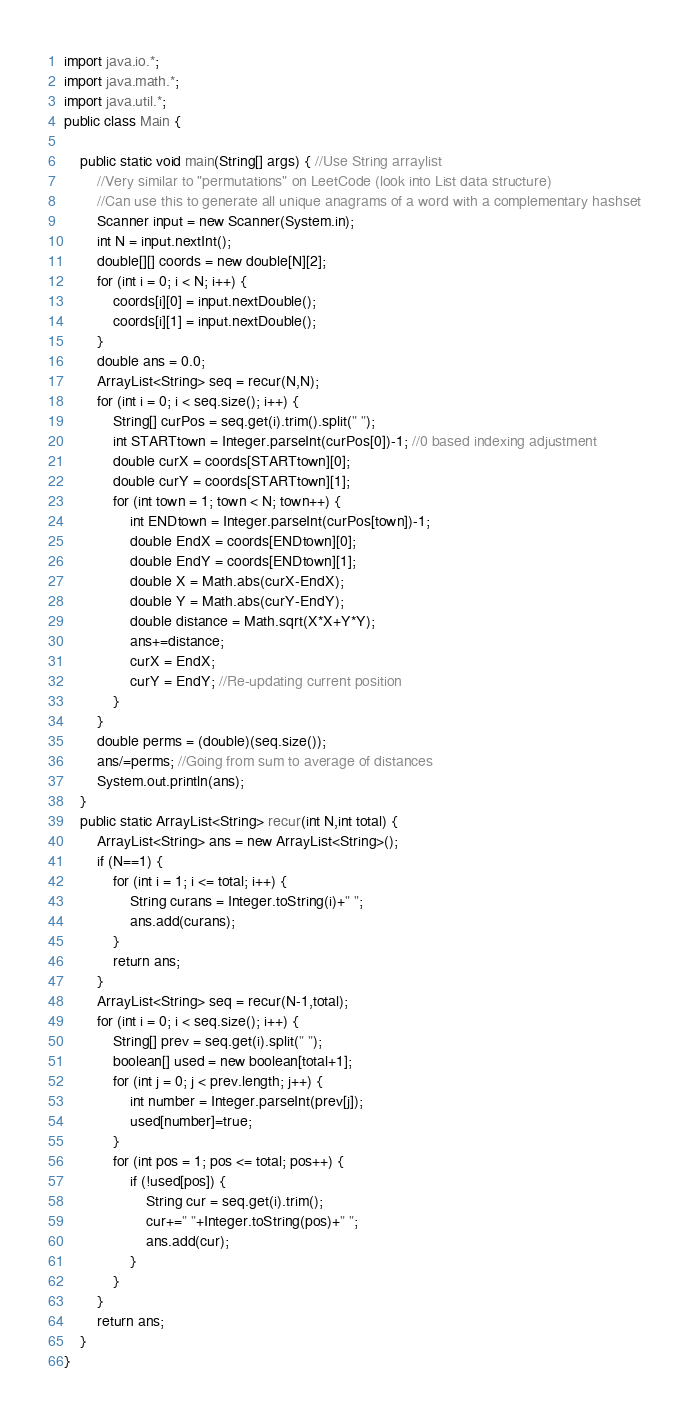<code> <loc_0><loc_0><loc_500><loc_500><_Java_>import java.io.*;
import java.math.*;
import java.util.*;
public class Main { 

	public static void main(String[] args) { //Use String arraylist
		//Very similar to "permutations" on LeetCode (look into List data structure)
		//Can use this to generate all unique anagrams of a word with a complementary hashset
		Scanner input = new Scanner(System.in);
		int N = input.nextInt();
		double[][] coords = new double[N][2];
		for (int i = 0; i < N; i++) {
			coords[i][0] = input.nextDouble();
			coords[i][1] = input.nextDouble();
		}
		double ans = 0.0;
		ArrayList<String> seq = recur(N,N);
		for (int i = 0; i < seq.size(); i++) {
			String[] curPos = seq.get(i).trim().split(" ");
			int STARTtown = Integer.parseInt(curPos[0])-1; //0 based indexing adjustment
			double curX = coords[STARTtown][0];
			double curY = coords[STARTtown][1];
			for (int town = 1; town < N; town++) {
				int ENDtown = Integer.parseInt(curPos[town])-1;
				double EndX = coords[ENDtown][0];
				double EndY = coords[ENDtown][1];
				double X = Math.abs(curX-EndX);
				double Y = Math.abs(curY-EndY);
				double distance = Math.sqrt(X*X+Y*Y);
				ans+=distance;
				curX = EndX;
				curY = EndY; //Re-updating current position
			}
		}
		double perms = (double)(seq.size());
		ans/=perms; //Going from sum to average of distances
		System.out.println(ans);
	}	
	public static ArrayList<String> recur(int N,int total) {
		ArrayList<String> ans = new ArrayList<String>();
		if (N==1) {
			for (int i = 1; i <= total; i++) {
				String curans = Integer.toString(i)+" ";
				ans.add(curans);
			}
			return ans;
		}
		ArrayList<String> seq = recur(N-1,total);
		for (int i = 0; i < seq.size(); i++) {
			String[] prev = seq.get(i).split(" ");
			boolean[] used = new boolean[total+1]; 
			for (int j = 0; j < prev.length; j++) {
				int number = Integer.parseInt(prev[j]);
				used[number]=true;
			}
			for (int pos = 1; pos <= total; pos++) {
				if (!used[pos]) {
					String cur = seq.get(i).trim();
					cur+=" "+Integer.toString(pos)+" ";
					ans.add(cur);
				}
			}
		}
		return ans;
	}
}</code> 